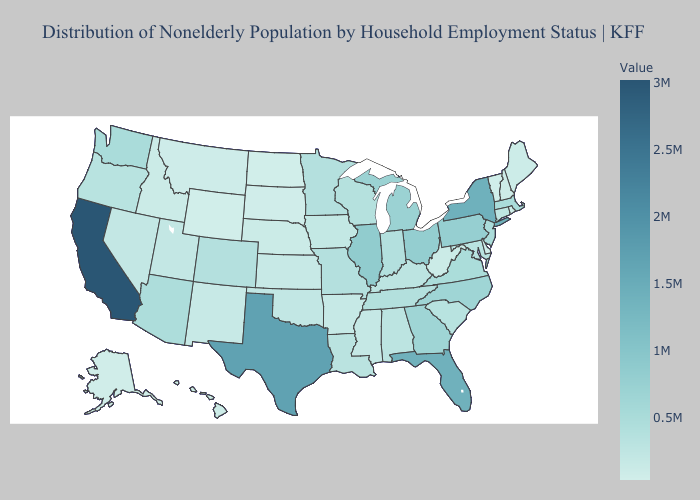Does Kentucky have the highest value in the South?
Short answer required. No. Does Indiana have a lower value than South Dakota?
Be succinct. No. Among the states that border Minnesota , which have the lowest value?
Give a very brief answer. North Dakota. Does California have the highest value in the USA?
Concise answer only. Yes. Does Wyoming have the lowest value in the USA?
Concise answer only. Yes. Does Washington have the highest value in the USA?
Keep it brief. No. Among the states that border Kentucky , which have the highest value?
Quick response, please. Illinois. Does the map have missing data?
Be succinct. No. Does Mississippi have a higher value than Virginia?
Write a very short answer. No. 